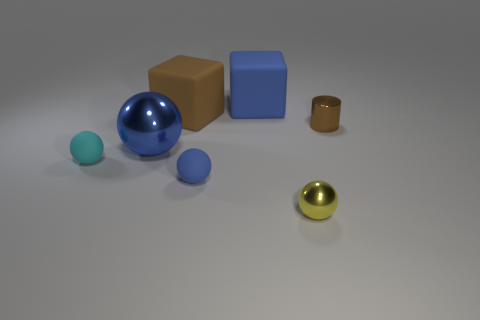What textures can you identify in the objects presented? The textures in the image vary: the metal balls have a shiny, reflective texture, the blue and brown blocks appear to have a matte, rubber-like texture, and the surface on which all objects rest seems quite smooth. 